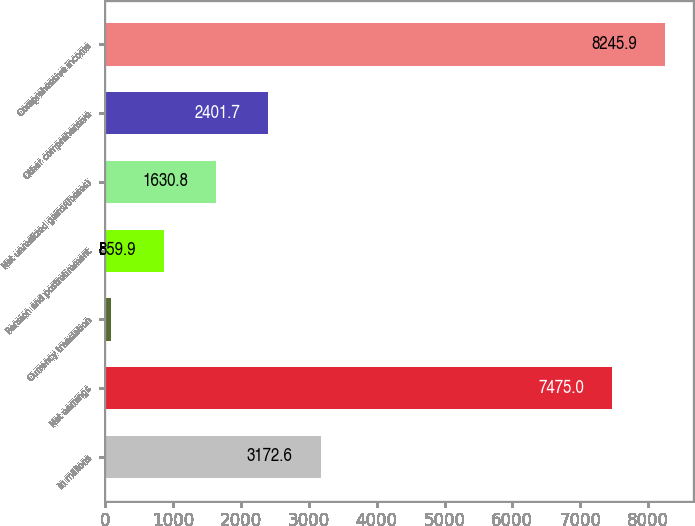Convert chart to OTSL. <chart><loc_0><loc_0><loc_500><loc_500><bar_chart><fcel>in millions<fcel>Net earnings<fcel>Currency translation<fcel>Pension and postretirement<fcel>Net unrealized gains/(losses)<fcel>Other comprehensive<fcel>Comprehensive income<nl><fcel>3172.6<fcel>7475<fcel>89<fcel>859.9<fcel>1630.8<fcel>2401.7<fcel>8245.9<nl></chart> 